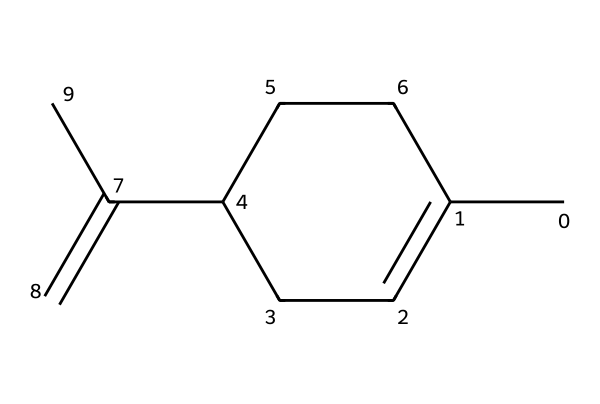What is the name of this chemical compound? The given SMILES representation corresponds to the structure of limonene, a natural compound commonly found in citrus fruits and used for its pleasant scent in cleaning products.
Answer: limonene How many carbon atoms are in limonene? When analyzing the SMILES representation, there are a total of 10 carbon atoms present within the structure of the molecule, indicated by each occurrence of the letter 'C'.
Answer: 10 What type of bond is primarily found in limonene? The structure shows mainly single bonds connecting the carbon atoms in the cyclohexene (ring) part and double bonds between specific carbon atoms, indicating it is primarily an alkene.
Answer: alkene How many double bonds does limonene have? Upon examining the structure, limonene contains one double bond between two carbon atoms, which can be seen in its linear arrangement.
Answer: 1 Which functional group is present in limonene? The structure suggests the presence of a double bond in the carbon chain. However, limonene primarily consists of carbon and hydrogen without any distinct functional groups such as hydroxyl or carboxylic groups.
Answer: none What is the molecular formula of limonene? By counting the atoms from the SMILES representation, the full molecular formula can be determined as C10H16, based on the 10 carbon and 16 hydrogen atoms present.
Answer: C10H16 How does the cyclic structure affect the properties of limonene? The cyclic (cyclohexene) structure of limonene contributes to its unique odor properties and stability compared to linear alkenes, also influencing its solubility and reactivity in various applications.
Answer: increases stability 